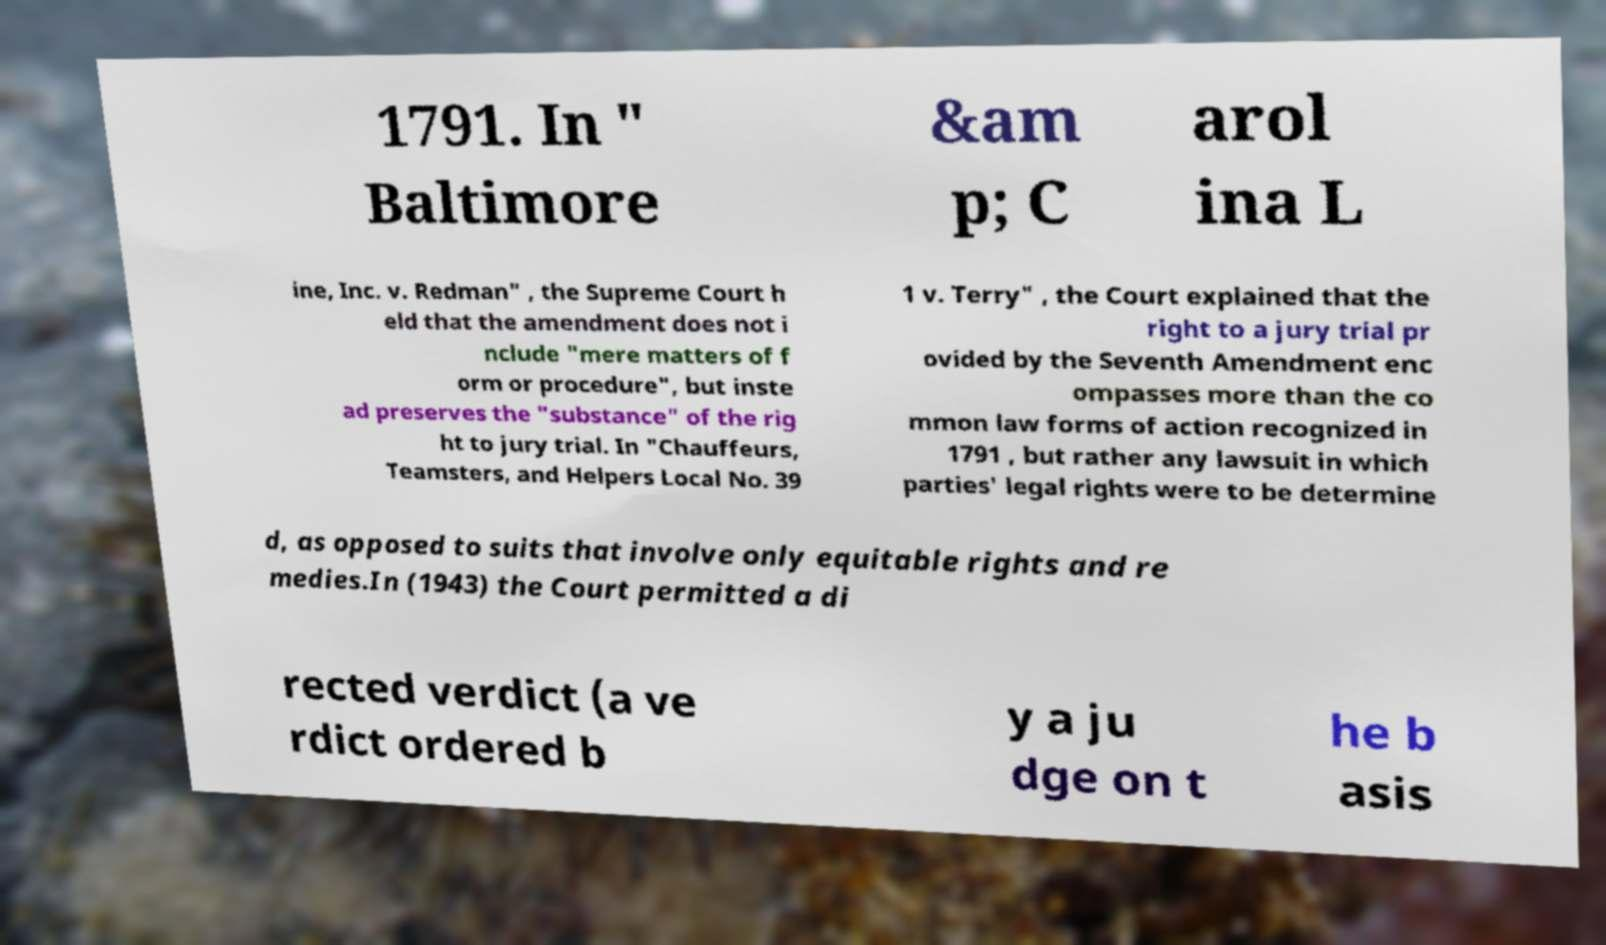What messages or text are displayed in this image? I need them in a readable, typed format. 1791. In " Baltimore &am p; C arol ina L ine, Inc. v. Redman" , the Supreme Court h eld that the amendment does not i nclude "mere matters of f orm or procedure", but inste ad preserves the "substance" of the rig ht to jury trial. In "Chauffeurs, Teamsters, and Helpers Local No. 39 1 v. Terry" , the Court explained that the right to a jury trial pr ovided by the Seventh Amendment enc ompasses more than the co mmon law forms of action recognized in 1791 , but rather any lawsuit in which parties' legal rights were to be determine d, as opposed to suits that involve only equitable rights and re medies.In (1943) the Court permitted a di rected verdict (a ve rdict ordered b y a ju dge on t he b asis 